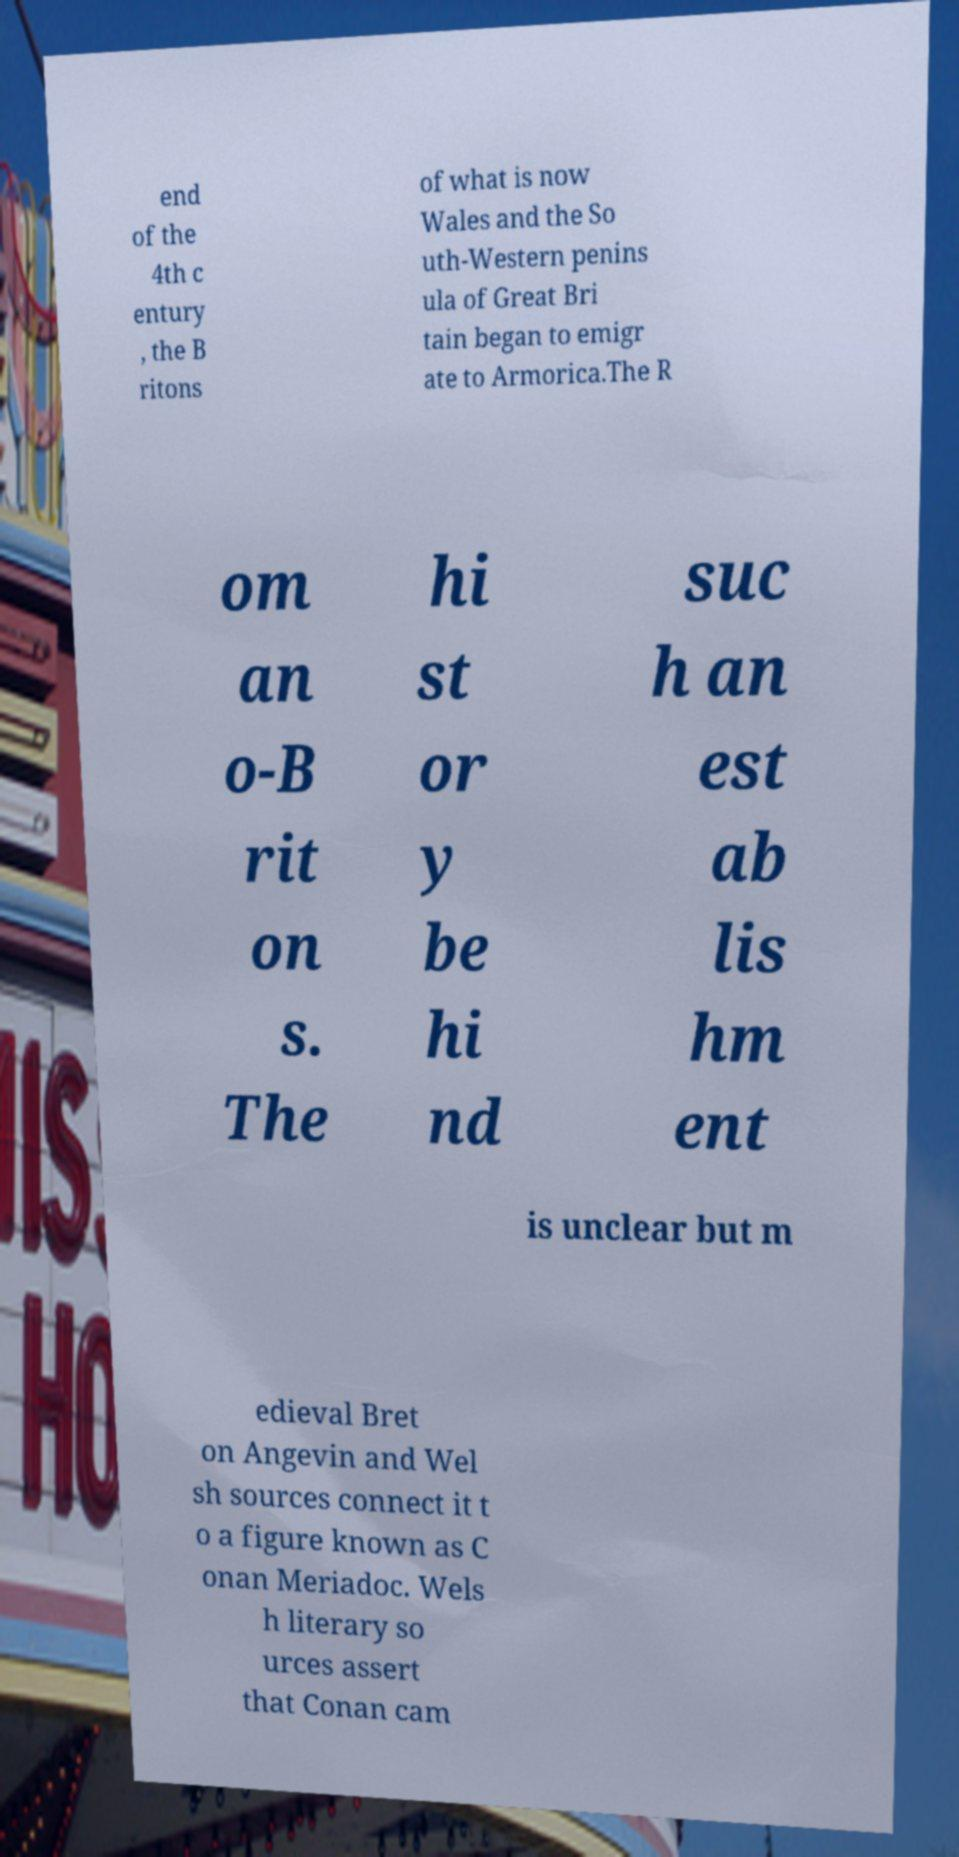Please identify and transcribe the text found in this image. end of the 4th c entury , the B ritons of what is now Wales and the So uth-Western penins ula of Great Bri tain began to emigr ate to Armorica.The R om an o-B rit on s. The hi st or y be hi nd suc h an est ab lis hm ent is unclear but m edieval Bret on Angevin and Wel sh sources connect it t o a figure known as C onan Meriadoc. Wels h literary so urces assert that Conan cam 